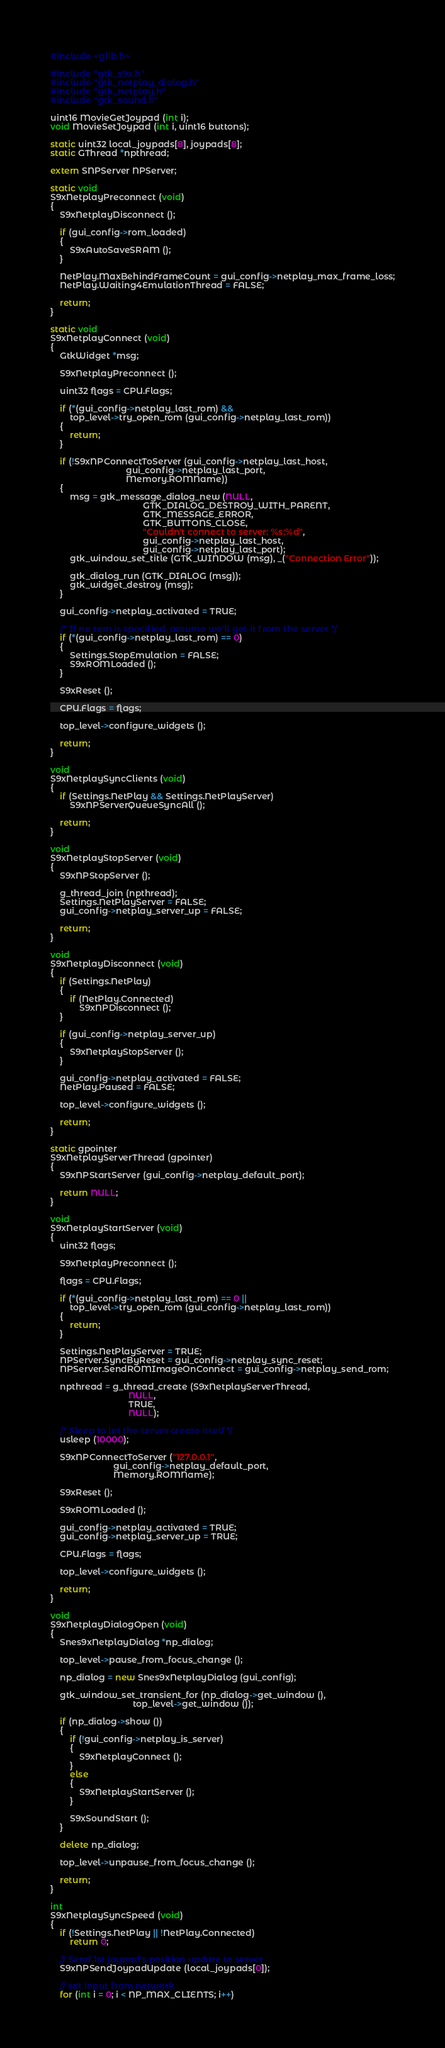Convert code to text. <code><loc_0><loc_0><loc_500><loc_500><_C++_>#include <glib.h>

#include "gtk_s9x.h"
#include "gtk_netplay_dialog.h"
#include "gtk_netplay.h"
#include "gtk_sound.h"

uint16 MovieGetJoypad (int i);
void MovieSetJoypad (int i, uint16 buttons);

static uint32 local_joypads[8], joypads[8];
static GThread *npthread;

extern SNPServer NPServer;

static void
S9xNetplayPreconnect (void)
{
    S9xNetplayDisconnect ();

    if (gui_config->rom_loaded)
    {
        S9xAutoSaveSRAM ();
    }

    NetPlay.MaxBehindFrameCount = gui_config->netplay_max_frame_loss;
    NetPlay.Waiting4EmulationThread = FALSE;

    return;
}

static void
S9xNetplayConnect (void)
{
    GtkWidget *msg;

    S9xNetplayPreconnect ();

    uint32 flags = CPU.Flags;

    if (*(gui_config->netplay_last_rom) &&
        top_level->try_open_rom (gui_config->netplay_last_rom))
    {
        return;
    }

    if (!S9xNPConnectToServer (gui_config->netplay_last_host,
                               gui_config->netplay_last_port,
                               Memory.ROMName))
    {
        msg = gtk_message_dialog_new (NULL,
                                      GTK_DIALOG_DESTROY_WITH_PARENT,
                                      GTK_MESSAGE_ERROR,
                                      GTK_BUTTONS_CLOSE,
                                      "Couldn't connect to server: %s:%d",
                                      gui_config->netplay_last_host,
                                      gui_config->netplay_last_port);
        gtk_window_set_title (GTK_WINDOW (msg), _("Connection Error"));

        gtk_dialog_run (GTK_DIALOG (msg));
        gtk_widget_destroy (msg);
    }

    gui_config->netplay_activated = TRUE;

    /* If no rom is specified, assume we'll get it from the server */
    if (*(gui_config->netplay_last_rom) == 0)
    {
        Settings.StopEmulation = FALSE;
        S9xROMLoaded ();
    }

    S9xReset ();

    CPU.Flags = flags;

    top_level->configure_widgets ();

    return;
}

void
S9xNetplaySyncClients (void)
{
    if (Settings.NetPlay && Settings.NetPlayServer)
        S9xNPServerQueueSyncAll ();

    return;
}

void
S9xNetplayStopServer (void)
{
    S9xNPStopServer ();

    g_thread_join (npthread);
    Settings.NetPlayServer = FALSE;
    gui_config->netplay_server_up = FALSE;

    return;
}

void
S9xNetplayDisconnect (void)
{
    if (Settings.NetPlay)
    {
        if (NetPlay.Connected)
            S9xNPDisconnect ();
    }

    if (gui_config->netplay_server_up)
    {
        S9xNetplayStopServer ();
    }

    gui_config->netplay_activated = FALSE;
    NetPlay.Paused = FALSE;

    top_level->configure_widgets ();

    return;
}

static gpointer
S9xNetplayServerThread (gpointer)
{
    S9xNPStartServer (gui_config->netplay_default_port);

    return NULL;
}

void
S9xNetplayStartServer (void)
{
    uint32 flags;

    S9xNetplayPreconnect ();

    flags = CPU.Flags;

    if (*(gui_config->netplay_last_rom) == 0 ||
        top_level->try_open_rom (gui_config->netplay_last_rom))
    {
        return;
    }

    Settings.NetPlayServer = TRUE;
    NPServer.SyncByReset = gui_config->netplay_sync_reset;
    NPServer.SendROMImageOnConnect = gui_config->netplay_send_rom;

    npthread = g_thread_create (S9xNetplayServerThread,
                                NULL,
                                TRUE,
                                NULL);

    /* Sleep to let the server create itself */
    usleep (10000);

    S9xNPConnectToServer ("127.0.0.1",
                          gui_config->netplay_default_port,
                          Memory.ROMName);

    S9xReset ();

    S9xROMLoaded ();

    gui_config->netplay_activated = TRUE;
    gui_config->netplay_server_up = TRUE;

    CPU.Flags = flags;

    top_level->configure_widgets ();

    return;
}

void
S9xNetplayDialogOpen (void)
{
    Snes9xNetplayDialog *np_dialog;

    top_level->pause_from_focus_change ();

    np_dialog = new Snes9xNetplayDialog (gui_config);

    gtk_window_set_transient_for (np_dialog->get_window (),
                                  top_level->get_window ());

    if (np_dialog->show ())
    {
        if (!gui_config->netplay_is_server)
        {
            S9xNetplayConnect ();
        }
        else
        {
            S9xNetplayStartServer ();
        }

        S9xSoundStart ();
    }

    delete np_dialog;

    top_level->unpause_from_focus_change ();

    return;
}

int
S9xNetplaySyncSpeed (void)
{
    if (!Settings.NetPlay || !NetPlay.Connected)
        return 0;

    // Send 1st joypad's position update to server
    S9xNPSendJoypadUpdate (local_joypads[0]);

    // set input from network
    for (int i = 0; i < NP_MAX_CLIENTS; i++)</code> 